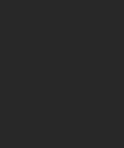Convert code to text. <code><loc_0><loc_0><loc_500><loc_500><_YAML_>

</code> 